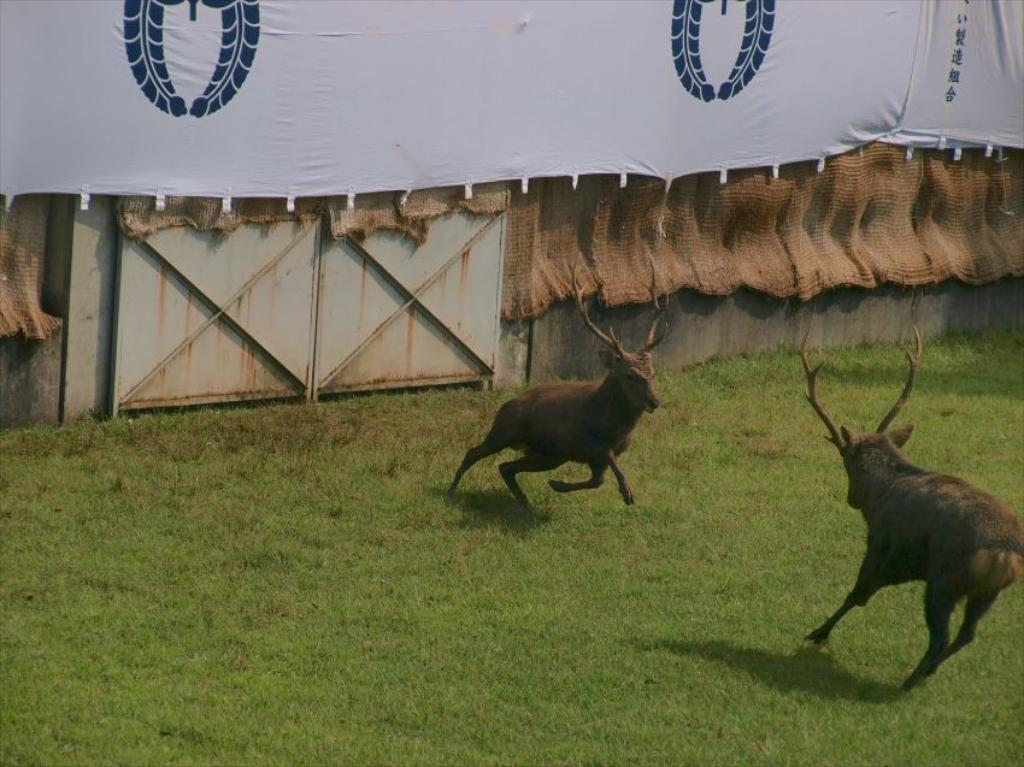What type of animals can be seen on the ground in the image? There are animals on the ground in the image. What can be seen in the background of the image? There is a banner in the background of the image. What type of clothing is visible in the image? Jute clothes are visible in the image. What is attached to the wall in the image? There are boards on the wall in the image. What type of pan is being used by the animal in the image? There is no pan present in the image, and no animals are shown using any tools or objects. 